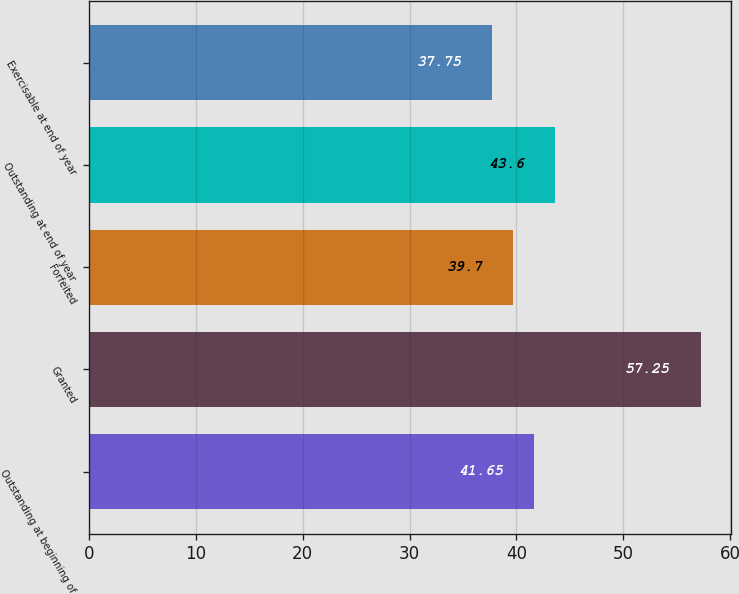<chart> <loc_0><loc_0><loc_500><loc_500><bar_chart><fcel>Outstanding at beginning of<fcel>Granted<fcel>Forfeited<fcel>Outstanding at end of year<fcel>Exercisable at end of year<nl><fcel>41.65<fcel>57.25<fcel>39.7<fcel>43.6<fcel>37.75<nl></chart> 